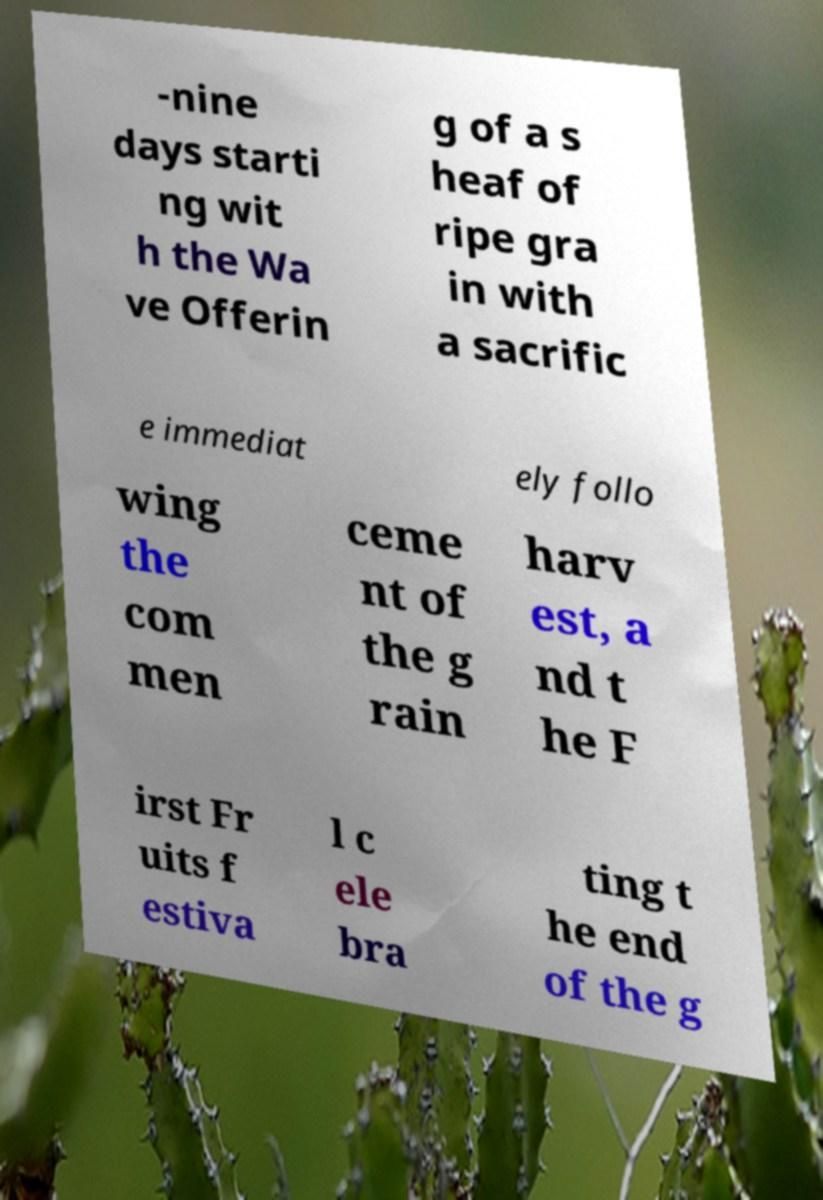Please read and relay the text visible in this image. What does it say? -nine days starti ng wit h the Wa ve Offerin g of a s heaf of ripe gra in with a sacrific e immediat ely follo wing the com men ceme nt of the g rain harv est, a nd t he F irst Fr uits f estiva l c ele bra ting t he end of the g 